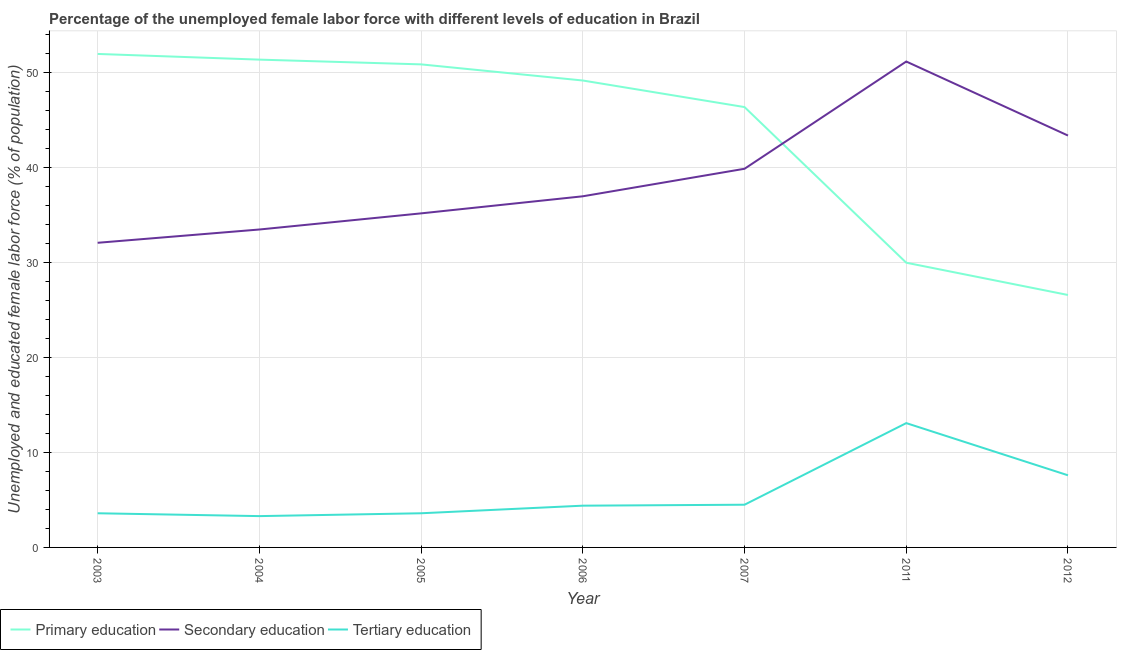How many different coloured lines are there?
Your answer should be very brief. 3. Does the line corresponding to percentage of female labor force who received tertiary education intersect with the line corresponding to percentage of female labor force who received primary education?
Provide a succinct answer. No. Is the number of lines equal to the number of legend labels?
Offer a terse response. Yes. What is the percentage of female labor force who received primary education in 2006?
Keep it short and to the point. 49.2. Across all years, what is the maximum percentage of female labor force who received tertiary education?
Keep it short and to the point. 13.1. Across all years, what is the minimum percentage of female labor force who received secondary education?
Give a very brief answer. 32.1. What is the total percentage of female labor force who received secondary education in the graph?
Offer a very short reply. 272.3. What is the difference between the percentage of female labor force who received tertiary education in 2006 and that in 2011?
Your response must be concise. -8.7. What is the difference between the percentage of female labor force who received tertiary education in 2012 and the percentage of female labor force who received secondary education in 2011?
Keep it short and to the point. -43.6. What is the average percentage of female labor force who received secondary education per year?
Offer a terse response. 38.9. In the year 2012, what is the difference between the percentage of female labor force who received primary education and percentage of female labor force who received secondary education?
Provide a succinct answer. -16.8. What is the ratio of the percentage of female labor force who received secondary education in 2004 to that in 2007?
Give a very brief answer. 0.84. Is the percentage of female labor force who received tertiary education in 2005 less than that in 2011?
Offer a terse response. Yes. Is the difference between the percentage of female labor force who received primary education in 2003 and 2006 greater than the difference between the percentage of female labor force who received tertiary education in 2003 and 2006?
Your answer should be very brief. Yes. What is the difference between the highest and the second highest percentage of female labor force who received tertiary education?
Keep it short and to the point. 5.5. What is the difference between the highest and the lowest percentage of female labor force who received tertiary education?
Your answer should be very brief. 9.8. In how many years, is the percentage of female labor force who received primary education greater than the average percentage of female labor force who received primary education taken over all years?
Ensure brevity in your answer.  5. Is it the case that in every year, the sum of the percentage of female labor force who received primary education and percentage of female labor force who received secondary education is greater than the percentage of female labor force who received tertiary education?
Your response must be concise. Yes. Does the percentage of female labor force who received tertiary education monotonically increase over the years?
Your response must be concise. No. Is the percentage of female labor force who received primary education strictly greater than the percentage of female labor force who received secondary education over the years?
Make the answer very short. No. How many years are there in the graph?
Your response must be concise. 7. Are the values on the major ticks of Y-axis written in scientific E-notation?
Provide a short and direct response. No. Does the graph contain any zero values?
Your answer should be very brief. No. What is the title of the graph?
Your answer should be compact. Percentage of the unemployed female labor force with different levels of education in Brazil. Does "Interest" appear as one of the legend labels in the graph?
Provide a short and direct response. No. What is the label or title of the X-axis?
Offer a very short reply. Year. What is the label or title of the Y-axis?
Make the answer very short. Unemployed and educated female labor force (% of population). What is the Unemployed and educated female labor force (% of population) of Primary education in 2003?
Provide a short and direct response. 52. What is the Unemployed and educated female labor force (% of population) in Secondary education in 2003?
Your answer should be compact. 32.1. What is the Unemployed and educated female labor force (% of population) of Tertiary education in 2003?
Keep it short and to the point. 3.6. What is the Unemployed and educated female labor force (% of population) in Primary education in 2004?
Ensure brevity in your answer.  51.4. What is the Unemployed and educated female labor force (% of population) of Secondary education in 2004?
Your answer should be very brief. 33.5. What is the Unemployed and educated female labor force (% of population) of Tertiary education in 2004?
Your response must be concise. 3.3. What is the Unemployed and educated female labor force (% of population) in Primary education in 2005?
Provide a succinct answer. 50.9. What is the Unemployed and educated female labor force (% of population) of Secondary education in 2005?
Offer a very short reply. 35.2. What is the Unemployed and educated female labor force (% of population) in Tertiary education in 2005?
Give a very brief answer. 3.6. What is the Unemployed and educated female labor force (% of population) of Primary education in 2006?
Give a very brief answer. 49.2. What is the Unemployed and educated female labor force (% of population) in Secondary education in 2006?
Offer a very short reply. 37. What is the Unemployed and educated female labor force (% of population) of Tertiary education in 2006?
Your answer should be very brief. 4.4. What is the Unemployed and educated female labor force (% of population) in Primary education in 2007?
Your response must be concise. 46.4. What is the Unemployed and educated female labor force (% of population) in Secondary education in 2007?
Provide a succinct answer. 39.9. What is the Unemployed and educated female labor force (% of population) in Tertiary education in 2007?
Your response must be concise. 4.5. What is the Unemployed and educated female labor force (% of population) of Primary education in 2011?
Offer a very short reply. 30. What is the Unemployed and educated female labor force (% of population) of Secondary education in 2011?
Make the answer very short. 51.2. What is the Unemployed and educated female labor force (% of population) in Tertiary education in 2011?
Offer a very short reply. 13.1. What is the Unemployed and educated female labor force (% of population) of Primary education in 2012?
Provide a succinct answer. 26.6. What is the Unemployed and educated female labor force (% of population) of Secondary education in 2012?
Your answer should be very brief. 43.4. What is the Unemployed and educated female labor force (% of population) of Tertiary education in 2012?
Your answer should be very brief. 7.6. Across all years, what is the maximum Unemployed and educated female labor force (% of population) of Primary education?
Ensure brevity in your answer.  52. Across all years, what is the maximum Unemployed and educated female labor force (% of population) of Secondary education?
Your answer should be compact. 51.2. Across all years, what is the maximum Unemployed and educated female labor force (% of population) of Tertiary education?
Provide a short and direct response. 13.1. Across all years, what is the minimum Unemployed and educated female labor force (% of population) of Primary education?
Ensure brevity in your answer.  26.6. Across all years, what is the minimum Unemployed and educated female labor force (% of population) in Secondary education?
Your answer should be very brief. 32.1. Across all years, what is the minimum Unemployed and educated female labor force (% of population) of Tertiary education?
Your answer should be compact. 3.3. What is the total Unemployed and educated female labor force (% of population) in Primary education in the graph?
Make the answer very short. 306.5. What is the total Unemployed and educated female labor force (% of population) in Secondary education in the graph?
Your response must be concise. 272.3. What is the total Unemployed and educated female labor force (% of population) of Tertiary education in the graph?
Provide a short and direct response. 40.1. What is the difference between the Unemployed and educated female labor force (% of population) in Primary education in 2003 and that in 2005?
Your answer should be very brief. 1.1. What is the difference between the Unemployed and educated female labor force (% of population) in Secondary education in 2003 and that in 2005?
Your answer should be compact. -3.1. What is the difference between the Unemployed and educated female labor force (% of population) in Primary education in 2003 and that in 2006?
Offer a very short reply. 2.8. What is the difference between the Unemployed and educated female labor force (% of population) of Tertiary education in 2003 and that in 2006?
Your response must be concise. -0.8. What is the difference between the Unemployed and educated female labor force (% of population) of Primary education in 2003 and that in 2007?
Provide a succinct answer. 5.6. What is the difference between the Unemployed and educated female labor force (% of population) of Primary education in 2003 and that in 2011?
Your answer should be compact. 22. What is the difference between the Unemployed and educated female labor force (% of population) in Secondary education in 2003 and that in 2011?
Provide a succinct answer. -19.1. What is the difference between the Unemployed and educated female labor force (% of population) in Primary education in 2003 and that in 2012?
Give a very brief answer. 25.4. What is the difference between the Unemployed and educated female labor force (% of population) of Primary education in 2004 and that in 2005?
Your answer should be compact. 0.5. What is the difference between the Unemployed and educated female labor force (% of population) of Secondary education in 2004 and that in 2005?
Your response must be concise. -1.7. What is the difference between the Unemployed and educated female labor force (% of population) in Tertiary education in 2004 and that in 2005?
Offer a terse response. -0.3. What is the difference between the Unemployed and educated female labor force (% of population) of Primary education in 2004 and that in 2006?
Provide a short and direct response. 2.2. What is the difference between the Unemployed and educated female labor force (% of population) of Secondary education in 2004 and that in 2006?
Offer a terse response. -3.5. What is the difference between the Unemployed and educated female labor force (% of population) in Tertiary education in 2004 and that in 2006?
Your answer should be compact. -1.1. What is the difference between the Unemployed and educated female labor force (% of population) in Primary education in 2004 and that in 2007?
Keep it short and to the point. 5. What is the difference between the Unemployed and educated female labor force (% of population) in Tertiary education in 2004 and that in 2007?
Your response must be concise. -1.2. What is the difference between the Unemployed and educated female labor force (% of population) of Primary education in 2004 and that in 2011?
Your answer should be compact. 21.4. What is the difference between the Unemployed and educated female labor force (% of population) in Secondary education in 2004 and that in 2011?
Provide a short and direct response. -17.7. What is the difference between the Unemployed and educated female labor force (% of population) in Primary education in 2004 and that in 2012?
Provide a short and direct response. 24.8. What is the difference between the Unemployed and educated female labor force (% of population) in Tertiary education in 2004 and that in 2012?
Ensure brevity in your answer.  -4.3. What is the difference between the Unemployed and educated female labor force (% of population) of Primary education in 2005 and that in 2006?
Give a very brief answer. 1.7. What is the difference between the Unemployed and educated female labor force (% of population) in Secondary education in 2005 and that in 2006?
Provide a succinct answer. -1.8. What is the difference between the Unemployed and educated female labor force (% of population) of Primary education in 2005 and that in 2007?
Provide a succinct answer. 4.5. What is the difference between the Unemployed and educated female labor force (% of population) in Secondary education in 2005 and that in 2007?
Offer a terse response. -4.7. What is the difference between the Unemployed and educated female labor force (% of population) in Primary education in 2005 and that in 2011?
Your response must be concise. 20.9. What is the difference between the Unemployed and educated female labor force (% of population) of Secondary education in 2005 and that in 2011?
Offer a very short reply. -16. What is the difference between the Unemployed and educated female labor force (% of population) of Primary education in 2005 and that in 2012?
Your answer should be very brief. 24.3. What is the difference between the Unemployed and educated female labor force (% of population) in Secondary education in 2005 and that in 2012?
Make the answer very short. -8.2. What is the difference between the Unemployed and educated female labor force (% of population) of Primary education in 2006 and that in 2007?
Give a very brief answer. 2.8. What is the difference between the Unemployed and educated female labor force (% of population) of Secondary education in 2006 and that in 2007?
Your answer should be very brief. -2.9. What is the difference between the Unemployed and educated female labor force (% of population) of Tertiary education in 2006 and that in 2007?
Provide a succinct answer. -0.1. What is the difference between the Unemployed and educated female labor force (% of population) of Primary education in 2006 and that in 2011?
Ensure brevity in your answer.  19.2. What is the difference between the Unemployed and educated female labor force (% of population) in Secondary education in 2006 and that in 2011?
Keep it short and to the point. -14.2. What is the difference between the Unemployed and educated female labor force (% of population) of Tertiary education in 2006 and that in 2011?
Your response must be concise. -8.7. What is the difference between the Unemployed and educated female labor force (% of population) in Primary education in 2006 and that in 2012?
Offer a terse response. 22.6. What is the difference between the Unemployed and educated female labor force (% of population) of Tertiary education in 2006 and that in 2012?
Make the answer very short. -3.2. What is the difference between the Unemployed and educated female labor force (% of population) in Primary education in 2007 and that in 2011?
Provide a short and direct response. 16.4. What is the difference between the Unemployed and educated female labor force (% of population) in Tertiary education in 2007 and that in 2011?
Provide a succinct answer. -8.6. What is the difference between the Unemployed and educated female labor force (% of population) in Primary education in 2007 and that in 2012?
Ensure brevity in your answer.  19.8. What is the difference between the Unemployed and educated female labor force (% of population) in Tertiary education in 2007 and that in 2012?
Provide a succinct answer. -3.1. What is the difference between the Unemployed and educated female labor force (% of population) of Primary education in 2011 and that in 2012?
Your answer should be compact. 3.4. What is the difference between the Unemployed and educated female labor force (% of population) of Secondary education in 2011 and that in 2012?
Give a very brief answer. 7.8. What is the difference between the Unemployed and educated female labor force (% of population) of Tertiary education in 2011 and that in 2012?
Provide a short and direct response. 5.5. What is the difference between the Unemployed and educated female labor force (% of population) in Primary education in 2003 and the Unemployed and educated female labor force (% of population) in Secondary education in 2004?
Keep it short and to the point. 18.5. What is the difference between the Unemployed and educated female labor force (% of population) in Primary education in 2003 and the Unemployed and educated female labor force (% of population) in Tertiary education in 2004?
Provide a succinct answer. 48.7. What is the difference between the Unemployed and educated female labor force (% of population) of Secondary education in 2003 and the Unemployed and educated female labor force (% of population) of Tertiary education in 2004?
Offer a very short reply. 28.8. What is the difference between the Unemployed and educated female labor force (% of population) of Primary education in 2003 and the Unemployed and educated female labor force (% of population) of Secondary education in 2005?
Provide a succinct answer. 16.8. What is the difference between the Unemployed and educated female labor force (% of population) in Primary education in 2003 and the Unemployed and educated female labor force (% of population) in Tertiary education in 2005?
Offer a terse response. 48.4. What is the difference between the Unemployed and educated female labor force (% of population) in Secondary education in 2003 and the Unemployed and educated female labor force (% of population) in Tertiary education in 2005?
Give a very brief answer. 28.5. What is the difference between the Unemployed and educated female labor force (% of population) in Primary education in 2003 and the Unemployed and educated female labor force (% of population) in Secondary education in 2006?
Keep it short and to the point. 15. What is the difference between the Unemployed and educated female labor force (% of population) in Primary education in 2003 and the Unemployed and educated female labor force (% of population) in Tertiary education in 2006?
Offer a terse response. 47.6. What is the difference between the Unemployed and educated female labor force (% of population) in Secondary education in 2003 and the Unemployed and educated female labor force (% of population) in Tertiary education in 2006?
Provide a succinct answer. 27.7. What is the difference between the Unemployed and educated female labor force (% of population) in Primary education in 2003 and the Unemployed and educated female labor force (% of population) in Tertiary education in 2007?
Ensure brevity in your answer.  47.5. What is the difference between the Unemployed and educated female labor force (% of population) in Secondary education in 2003 and the Unemployed and educated female labor force (% of population) in Tertiary education in 2007?
Make the answer very short. 27.6. What is the difference between the Unemployed and educated female labor force (% of population) in Primary education in 2003 and the Unemployed and educated female labor force (% of population) in Tertiary education in 2011?
Offer a terse response. 38.9. What is the difference between the Unemployed and educated female labor force (% of population) of Secondary education in 2003 and the Unemployed and educated female labor force (% of population) of Tertiary education in 2011?
Provide a short and direct response. 19. What is the difference between the Unemployed and educated female labor force (% of population) in Primary education in 2003 and the Unemployed and educated female labor force (% of population) in Tertiary education in 2012?
Your answer should be very brief. 44.4. What is the difference between the Unemployed and educated female labor force (% of population) of Primary education in 2004 and the Unemployed and educated female labor force (% of population) of Secondary education in 2005?
Give a very brief answer. 16.2. What is the difference between the Unemployed and educated female labor force (% of population) of Primary education in 2004 and the Unemployed and educated female labor force (% of population) of Tertiary education in 2005?
Give a very brief answer. 47.8. What is the difference between the Unemployed and educated female labor force (% of population) in Secondary education in 2004 and the Unemployed and educated female labor force (% of population) in Tertiary education in 2005?
Your answer should be compact. 29.9. What is the difference between the Unemployed and educated female labor force (% of population) in Primary education in 2004 and the Unemployed and educated female labor force (% of population) in Secondary education in 2006?
Keep it short and to the point. 14.4. What is the difference between the Unemployed and educated female labor force (% of population) of Secondary education in 2004 and the Unemployed and educated female labor force (% of population) of Tertiary education in 2006?
Your answer should be very brief. 29.1. What is the difference between the Unemployed and educated female labor force (% of population) in Primary education in 2004 and the Unemployed and educated female labor force (% of population) in Tertiary education in 2007?
Your response must be concise. 46.9. What is the difference between the Unemployed and educated female labor force (% of population) in Primary education in 2004 and the Unemployed and educated female labor force (% of population) in Secondary education in 2011?
Keep it short and to the point. 0.2. What is the difference between the Unemployed and educated female labor force (% of population) in Primary education in 2004 and the Unemployed and educated female labor force (% of population) in Tertiary education in 2011?
Keep it short and to the point. 38.3. What is the difference between the Unemployed and educated female labor force (% of population) in Secondary education in 2004 and the Unemployed and educated female labor force (% of population) in Tertiary education in 2011?
Ensure brevity in your answer.  20.4. What is the difference between the Unemployed and educated female labor force (% of population) in Primary education in 2004 and the Unemployed and educated female labor force (% of population) in Secondary education in 2012?
Ensure brevity in your answer.  8. What is the difference between the Unemployed and educated female labor force (% of population) of Primary education in 2004 and the Unemployed and educated female labor force (% of population) of Tertiary education in 2012?
Ensure brevity in your answer.  43.8. What is the difference between the Unemployed and educated female labor force (% of population) of Secondary education in 2004 and the Unemployed and educated female labor force (% of population) of Tertiary education in 2012?
Offer a very short reply. 25.9. What is the difference between the Unemployed and educated female labor force (% of population) of Primary education in 2005 and the Unemployed and educated female labor force (% of population) of Secondary education in 2006?
Your response must be concise. 13.9. What is the difference between the Unemployed and educated female labor force (% of population) in Primary education in 2005 and the Unemployed and educated female labor force (% of population) in Tertiary education in 2006?
Offer a very short reply. 46.5. What is the difference between the Unemployed and educated female labor force (% of population) in Secondary education in 2005 and the Unemployed and educated female labor force (% of population) in Tertiary education in 2006?
Your answer should be compact. 30.8. What is the difference between the Unemployed and educated female labor force (% of population) in Primary education in 2005 and the Unemployed and educated female labor force (% of population) in Tertiary education in 2007?
Your response must be concise. 46.4. What is the difference between the Unemployed and educated female labor force (% of population) of Secondary education in 2005 and the Unemployed and educated female labor force (% of population) of Tertiary education in 2007?
Make the answer very short. 30.7. What is the difference between the Unemployed and educated female labor force (% of population) of Primary education in 2005 and the Unemployed and educated female labor force (% of population) of Tertiary education in 2011?
Ensure brevity in your answer.  37.8. What is the difference between the Unemployed and educated female labor force (% of population) in Secondary education in 2005 and the Unemployed and educated female labor force (% of population) in Tertiary education in 2011?
Keep it short and to the point. 22.1. What is the difference between the Unemployed and educated female labor force (% of population) in Primary education in 2005 and the Unemployed and educated female labor force (% of population) in Secondary education in 2012?
Provide a short and direct response. 7.5. What is the difference between the Unemployed and educated female labor force (% of population) in Primary education in 2005 and the Unemployed and educated female labor force (% of population) in Tertiary education in 2012?
Make the answer very short. 43.3. What is the difference between the Unemployed and educated female labor force (% of population) in Secondary education in 2005 and the Unemployed and educated female labor force (% of population) in Tertiary education in 2012?
Keep it short and to the point. 27.6. What is the difference between the Unemployed and educated female labor force (% of population) of Primary education in 2006 and the Unemployed and educated female labor force (% of population) of Tertiary education in 2007?
Keep it short and to the point. 44.7. What is the difference between the Unemployed and educated female labor force (% of population) in Secondary education in 2006 and the Unemployed and educated female labor force (% of population) in Tertiary education in 2007?
Provide a short and direct response. 32.5. What is the difference between the Unemployed and educated female labor force (% of population) in Primary education in 2006 and the Unemployed and educated female labor force (% of population) in Tertiary education in 2011?
Provide a short and direct response. 36.1. What is the difference between the Unemployed and educated female labor force (% of population) in Secondary education in 2006 and the Unemployed and educated female labor force (% of population) in Tertiary education in 2011?
Provide a short and direct response. 23.9. What is the difference between the Unemployed and educated female labor force (% of population) in Primary education in 2006 and the Unemployed and educated female labor force (% of population) in Tertiary education in 2012?
Make the answer very short. 41.6. What is the difference between the Unemployed and educated female labor force (% of population) in Secondary education in 2006 and the Unemployed and educated female labor force (% of population) in Tertiary education in 2012?
Offer a terse response. 29.4. What is the difference between the Unemployed and educated female labor force (% of population) in Primary education in 2007 and the Unemployed and educated female labor force (% of population) in Tertiary education in 2011?
Your response must be concise. 33.3. What is the difference between the Unemployed and educated female labor force (% of population) in Secondary education in 2007 and the Unemployed and educated female labor force (% of population) in Tertiary education in 2011?
Make the answer very short. 26.8. What is the difference between the Unemployed and educated female labor force (% of population) in Primary education in 2007 and the Unemployed and educated female labor force (% of population) in Tertiary education in 2012?
Your answer should be very brief. 38.8. What is the difference between the Unemployed and educated female labor force (% of population) of Secondary education in 2007 and the Unemployed and educated female labor force (% of population) of Tertiary education in 2012?
Provide a short and direct response. 32.3. What is the difference between the Unemployed and educated female labor force (% of population) of Primary education in 2011 and the Unemployed and educated female labor force (% of population) of Secondary education in 2012?
Offer a terse response. -13.4. What is the difference between the Unemployed and educated female labor force (% of population) of Primary education in 2011 and the Unemployed and educated female labor force (% of population) of Tertiary education in 2012?
Offer a very short reply. 22.4. What is the difference between the Unemployed and educated female labor force (% of population) in Secondary education in 2011 and the Unemployed and educated female labor force (% of population) in Tertiary education in 2012?
Your answer should be compact. 43.6. What is the average Unemployed and educated female labor force (% of population) in Primary education per year?
Offer a terse response. 43.79. What is the average Unemployed and educated female labor force (% of population) of Secondary education per year?
Your response must be concise. 38.9. What is the average Unemployed and educated female labor force (% of population) in Tertiary education per year?
Ensure brevity in your answer.  5.73. In the year 2003, what is the difference between the Unemployed and educated female labor force (% of population) in Primary education and Unemployed and educated female labor force (% of population) in Tertiary education?
Offer a very short reply. 48.4. In the year 2004, what is the difference between the Unemployed and educated female labor force (% of population) of Primary education and Unemployed and educated female labor force (% of population) of Tertiary education?
Your answer should be very brief. 48.1. In the year 2004, what is the difference between the Unemployed and educated female labor force (% of population) in Secondary education and Unemployed and educated female labor force (% of population) in Tertiary education?
Ensure brevity in your answer.  30.2. In the year 2005, what is the difference between the Unemployed and educated female labor force (% of population) in Primary education and Unemployed and educated female labor force (% of population) in Secondary education?
Give a very brief answer. 15.7. In the year 2005, what is the difference between the Unemployed and educated female labor force (% of population) of Primary education and Unemployed and educated female labor force (% of population) of Tertiary education?
Ensure brevity in your answer.  47.3. In the year 2005, what is the difference between the Unemployed and educated female labor force (% of population) of Secondary education and Unemployed and educated female labor force (% of population) of Tertiary education?
Your answer should be compact. 31.6. In the year 2006, what is the difference between the Unemployed and educated female labor force (% of population) in Primary education and Unemployed and educated female labor force (% of population) in Secondary education?
Give a very brief answer. 12.2. In the year 2006, what is the difference between the Unemployed and educated female labor force (% of population) of Primary education and Unemployed and educated female labor force (% of population) of Tertiary education?
Ensure brevity in your answer.  44.8. In the year 2006, what is the difference between the Unemployed and educated female labor force (% of population) in Secondary education and Unemployed and educated female labor force (% of population) in Tertiary education?
Offer a terse response. 32.6. In the year 2007, what is the difference between the Unemployed and educated female labor force (% of population) in Primary education and Unemployed and educated female labor force (% of population) in Secondary education?
Provide a succinct answer. 6.5. In the year 2007, what is the difference between the Unemployed and educated female labor force (% of population) in Primary education and Unemployed and educated female labor force (% of population) in Tertiary education?
Your answer should be very brief. 41.9. In the year 2007, what is the difference between the Unemployed and educated female labor force (% of population) in Secondary education and Unemployed and educated female labor force (% of population) in Tertiary education?
Your answer should be compact. 35.4. In the year 2011, what is the difference between the Unemployed and educated female labor force (% of population) of Primary education and Unemployed and educated female labor force (% of population) of Secondary education?
Provide a short and direct response. -21.2. In the year 2011, what is the difference between the Unemployed and educated female labor force (% of population) in Secondary education and Unemployed and educated female labor force (% of population) in Tertiary education?
Offer a terse response. 38.1. In the year 2012, what is the difference between the Unemployed and educated female labor force (% of population) in Primary education and Unemployed and educated female labor force (% of population) in Secondary education?
Make the answer very short. -16.8. In the year 2012, what is the difference between the Unemployed and educated female labor force (% of population) of Secondary education and Unemployed and educated female labor force (% of population) of Tertiary education?
Provide a short and direct response. 35.8. What is the ratio of the Unemployed and educated female labor force (% of population) in Primary education in 2003 to that in 2004?
Keep it short and to the point. 1.01. What is the ratio of the Unemployed and educated female labor force (% of population) in Secondary education in 2003 to that in 2004?
Offer a very short reply. 0.96. What is the ratio of the Unemployed and educated female labor force (% of population) in Primary education in 2003 to that in 2005?
Your response must be concise. 1.02. What is the ratio of the Unemployed and educated female labor force (% of population) of Secondary education in 2003 to that in 2005?
Your response must be concise. 0.91. What is the ratio of the Unemployed and educated female labor force (% of population) of Tertiary education in 2003 to that in 2005?
Keep it short and to the point. 1. What is the ratio of the Unemployed and educated female labor force (% of population) of Primary education in 2003 to that in 2006?
Offer a very short reply. 1.06. What is the ratio of the Unemployed and educated female labor force (% of population) of Secondary education in 2003 to that in 2006?
Ensure brevity in your answer.  0.87. What is the ratio of the Unemployed and educated female labor force (% of population) in Tertiary education in 2003 to that in 2006?
Your answer should be very brief. 0.82. What is the ratio of the Unemployed and educated female labor force (% of population) in Primary education in 2003 to that in 2007?
Make the answer very short. 1.12. What is the ratio of the Unemployed and educated female labor force (% of population) in Secondary education in 2003 to that in 2007?
Give a very brief answer. 0.8. What is the ratio of the Unemployed and educated female labor force (% of population) in Tertiary education in 2003 to that in 2007?
Provide a succinct answer. 0.8. What is the ratio of the Unemployed and educated female labor force (% of population) in Primary education in 2003 to that in 2011?
Your answer should be very brief. 1.73. What is the ratio of the Unemployed and educated female labor force (% of population) in Secondary education in 2003 to that in 2011?
Your answer should be very brief. 0.63. What is the ratio of the Unemployed and educated female labor force (% of population) of Tertiary education in 2003 to that in 2011?
Ensure brevity in your answer.  0.27. What is the ratio of the Unemployed and educated female labor force (% of population) of Primary education in 2003 to that in 2012?
Offer a very short reply. 1.95. What is the ratio of the Unemployed and educated female labor force (% of population) of Secondary education in 2003 to that in 2012?
Ensure brevity in your answer.  0.74. What is the ratio of the Unemployed and educated female labor force (% of population) of Tertiary education in 2003 to that in 2012?
Ensure brevity in your answer.  0.47. What is the ratio of the Unemployed and educated female labor force (% of population) in Primary education in 2004 to that in 2005?
Your answer should be very brief. 1.01. What is the ratio of the Unemployed and educated female labor force (% of population) in Secondary education in 2004 to that in 2005?
Give a very brief answer. 0.95. What is the ratio of the Unemployed and educated female labor force (% of population) in Tertiary education in 2004 to that in 2005?
Provide a succinct answer. 0.92. What is the ratio of the Unemployed and educated female labor force (% of population) of Primary education in 2004 to that in 2006?
Your answer should be very brief. 1.04. What is the ratio of the Unemployed and educated female labor force (% of population) of Secondary education in 2004 to that in 2006?
Offer a very short reply. 0.91. What is the ratio of the Unemployed and educated female labor force (% of population) of Tertiary education in 2004 to that in 2006?
Provide a succinct answer. 0.75. What is the ratio of the Unemployed and educated female labor force (% of population) in Primary education in 2004 to that in 2007?
Provide a short and direct response. 1.11. What is the ratio of the Unemployed and educated female labor force (% of population) of Secondary education in 2004 to that in 2007?
Provide a short and direct response. 0.84. What is the ratio of the Unemployed and educated female labor force (% of population) of Tertiary education in 2004 to that in 2007?
Offer a terse response. 0.73. What is the ratio of the Unemployed and educated female labor force (% of population) of Primary education in 2004 to that in 2011?
Your answer should be compact. 1.71. What is the ratio of the Unemployed and educated female labor force (% of population) of Secondary education in 2004 to that in 2011?
Your answer should be very brief. 0.65. What is the ratio of the Unemployed and educated female labor force (% of population) in Tertiary education in 2004 to that in 2011?
Keep it short and to the point. 0.25. What is the ratio of the Unemployed and educated female labor force (% of population) in Primary education in 2004 to that in 2012?
Your response must be concise. 1.93. What is the ratio of the Unemployed and educated female labor force (% of population) of Secondary education in 2004 to that in 2012?
Your answer should be compact. 0.77. What is the ratio of the Unemployed and educated female labor force (% of population) of Tertiary education in 2004 to that in 2012?
Give a very brief answer. 0.43. What is the ratio of the Unemployed and educated female labor force (% of population) in Primary education in 2005 to that in 2006?
Provide a short and direct response. 1.03. What is the ratio of the Unemployed and educated female labor force (% of population) of Secondary education in 2005 to that in 2006?
Ensure brevity in your answer.  0.95. What is the ratio of the Unemployed and educated female labor force (% of population) of Tertiary education in 2005 to that in 2006?
Make the answer very short. 0.82. What is the ratio of the Unemployed and educated female labor force (% of population) of Primary education in 2005 to that in 2007?
Provide a short and direct response. 1.1. What is the ratio of the Unemployed and educated female labor force (% of population) of Secondary education in 2005 to that in 2007?
Your answer should be compact. 0.88. What is the ratio of the Unemployed and educated female labor force (% of population) of Tertiary education in 2005 to that in 2007?
Provide a succinct answer. 0.8. What is the ratio of the Unemployed and educated female labor force (% of population) in Primary education in 2005 to that in 2011?
Keep it short and to the point. 1.7. What is the ratio of the Unemployed and educated female labor force (% of population) of Secondary education in 2005 to that in 2011?
Give a very brief answer. 0.69. What is the ratio of the Unemployed and educated female labor force (% of population) of Tertiary education in 2005 to that in 2011?
Ensure brevity in your answer.  0.27. What is the ratio of the Unemployed and educated female labor force (% of population) of Primary education in 2005 to that in 2012?
Give a very brief answer. 1.91. What is the ratio of the Unemployed and educated female labor force (% of population) of Secondary education in 2005 to that in 2012?
Your answer should be compact. 0.81. What is the ratio of the Unemployed and educated female labor force (% of population) in Tertiary education in 2005 to that in 2012?
Provide a short and direct response. 0.47. What is the ratio of the Unemployed and educated female labor force (% of population) in Primary education in 2006 to that in 2007?
Provide a succinct answer. 1.06. What is the ratio of the Unemployed and educated female labor force (% of population) of Secondary education in 2006 to that in 2007?
Ensure brevity in your answer.  0.93. What is the ratio of the Unemployed and educated female labor force (% of population) in Tertiary education in 2006 to that in 2007?
Make the answer very short. 0.98. What is the ratio of the Unemployed and educated female labor force (% of population) of Primary education in 2006 to that in 2011?
Your answer should be very brief. 1.64. What is the ratio of the Unemployed and educated female labor force (% of population) in Secondary education in 2006 to that in 2011?
Keep it short and to the point. 0.72. What is the ratio of the Unemployed and educated female labor force (% of population) of Tertiary education in 2006 to that in 2011?
Give a very brief answer. 0.34. What is the ratio of the Unemployed and educated female labor force (% of population) in Primary education in 2006 to that in 2012?
Your answer should be very brief. 1.85. What is the ratio of the Unemployed and educated female labor force (% of population) of Secondary education in 2006 to that in 2012?
Offer a very short reply. 0.85. What is the ratio of the Unemployed and educated female labor force (% of population) in Tertiary education in 2006 to that in 2012?
Offer a terse response. 0.58. What is the ratio of the Unemployed and educated female labor force (% of population) in Primary education in 2007 to that in 2011?
Provide a succinct answer. 1.55. What is the ratio of the Unemployed and educated female labor force (% of population) of Secondary education in 2007 to that in 2011?
Keep it short and to the point. 0.78. What is the ratio of the Unemployed and educated female labor force (% of population) of Tertiary education in 2007 to that in 2011?
Ensure brevity in your answer.  0.34. What is the ratio of the Unemployed and educated female labor force (% of population) in Primary education in 2007 to that in 2012?
Your answer should be compact. 1.74. What is the ratio of the Unemployed and educated female labor force (% of population) of Secondary education in 2007 to that in 2012?
Your response must be concise. 0.92. What is the ratio of the Unemployed and educated female labor force (% of population) of Tertiary education in 2007 to that in 2012?
Make the answer very short. 0.59. What is the ratio of the Unemployed and educated female labor force (% of population) in Primary education in 2011 to that in 2012?
Your answer should be compact. 1.13. What is the ratio of the Unemployed and educated female labor force (% of population) in Secondary education in 2011 to that in 2012?
Make the answer very short. 1.18. What is the ratio of the Unemployed and educated female labor force (% of population) of Tertiary education in 2011 to that in 2012?
Keep it short and to the point. 1.72. What is the difference between the highest and the second highest Unemployed and educated female labor force (% of population) in Primary education?
Make the answer very short. 0.6. What is the difference between the highest and the second highest Unemployed and educated female labor force (% of population) in Secondary education?
Keep it short and to the point. 7.8. What is the difference between the highest and the lowest Unemployed and educated female labor force (% of population) of Primary education?
Offer a very short reply. 25.4. 